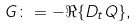Convert formula to latex. <formula><loc_0><loc_0><loc_500><loc_500>G \colon = - \Re \{ D _ { t } Q \} ,</formula> 